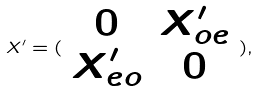<formula> <loc_0><loc_0><loc_500><loc_500>X ^ { \prime } = ( \begin{array} { c c } 0 & X _ { o e } ^ { \prime } \\ X _ { e o } ^ { \prime } & 0 \end{array} ) ,</formula> 